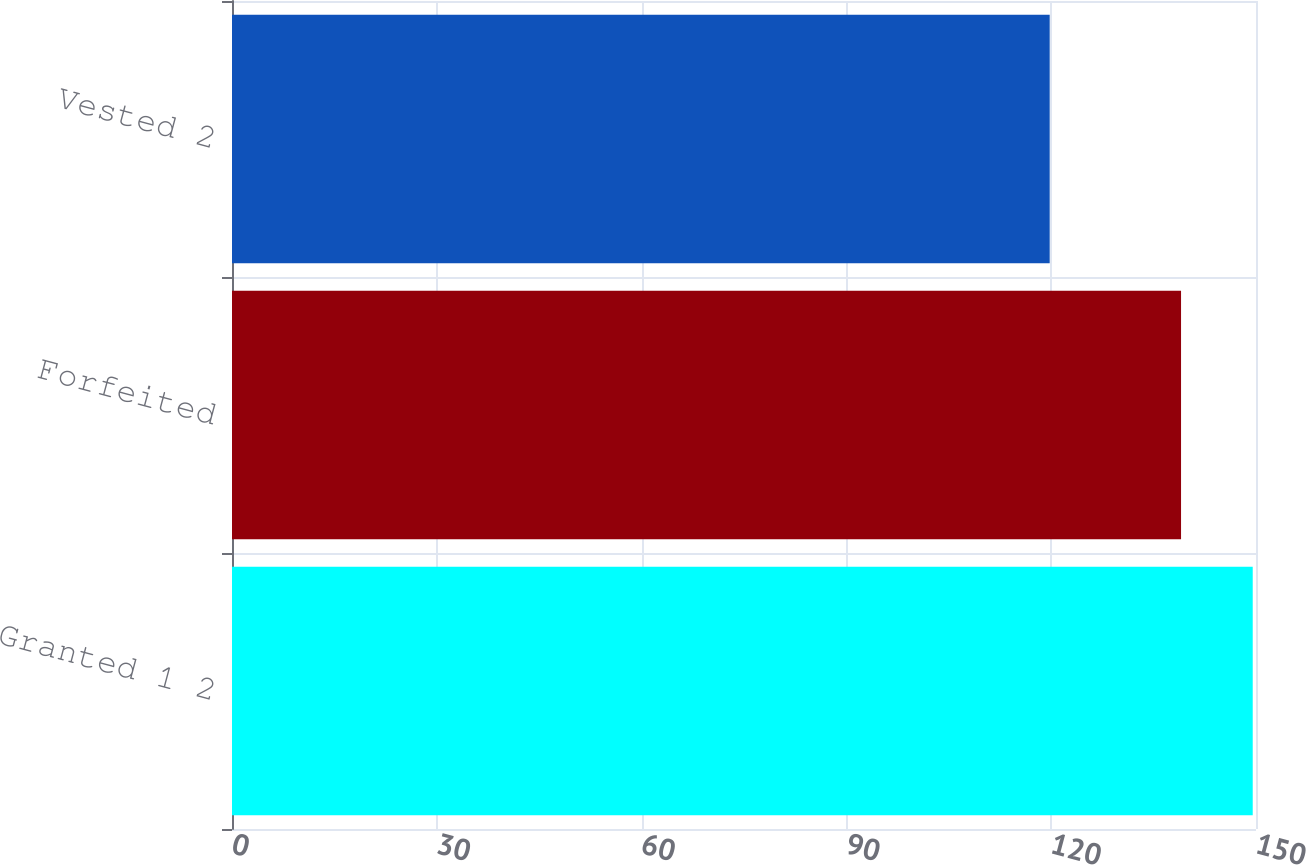Convert chart. <chart><loc_0><loc_0><loc_500><loc_500><bar_chart><fcel>Granted 1 2<fcel>Forfeited<fcel>Vested 2<nl><fcel>149.52<fcel>139.02<fcel>119.78<nl></chart> 